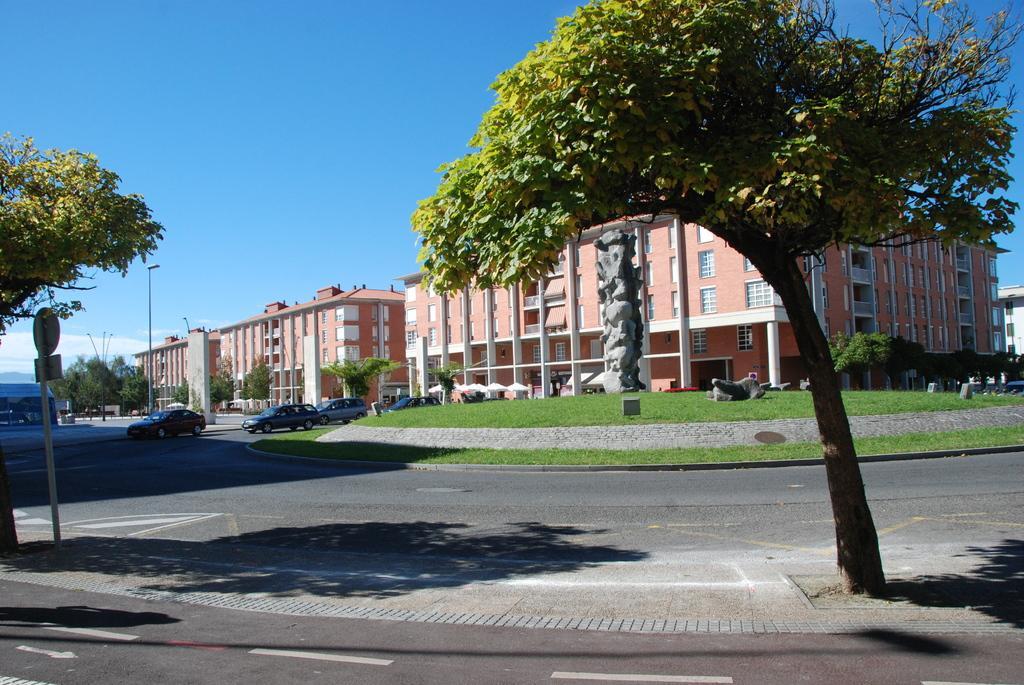Please provide a concise description of this image. This picture shows few buildings and trees and we see few cars and grass on the ground and a blue cloudy Sky. 